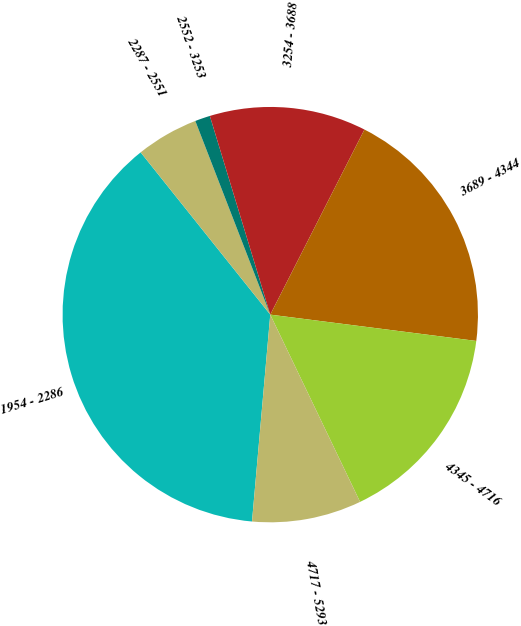Convert chart. <chart><loc_0><loc_0><loc_500><loc_500><pie_chart><fcel>1954 - 2286<fcel>2287 - 2551<fcel>2552 - 3253<fcel>3254 - 3688<fcel>3689 - 4344<fcel>4345 - 4716<fcel>4717 - 5293<nl><fcel>37.87%<fcel>4.85%<fcel>1.18%<fcel>12.19%<fcel>19.53%<fcel>15.86%<fcel>8.52%<nl></chart> 